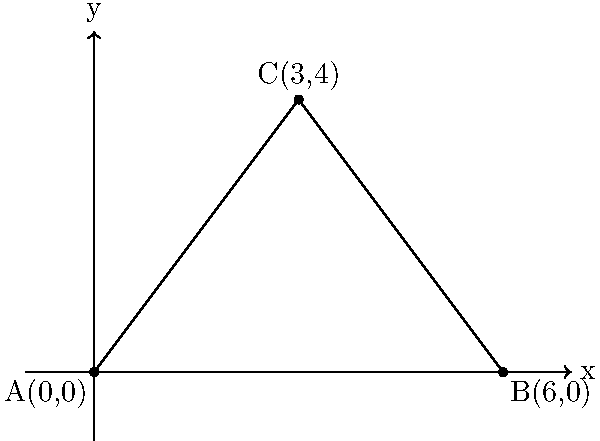As a supportive parent, you're helping your child understand geometry before their tattoo removal appointment. Given two points A(0,0) and B(6,0), find the coordinates of point C that forms an isosceles triangle ABC where AC = BC. The height of the triangle is 4 units. Let's approach this step-by-step:

1) Since A(0,0) and B(6,0) are on the x-axis, the base of the triangle is 6 units long.

2) The height of the triangle is given as 4 units, so C will be 4 units above the x-axis.

3) For an isosceles triangle with AC = BC, point C must be equidistant from A and B. This means C will be directly above the midpoint of AB.

4) The midpoint of AB is at $(\frac{0+6}{2}, 0) = (3,0)$.

5) Therefore, the coordinates of C will be (3,4).

To verify:
- AC = $\sqrt{3^2 + 4^2} = 5$
- BC = $\sqrt{3^2 + 4^2} = 5$

Thus, AC = BC, confirming that ABC is indeed an isosceles triangle.
Answer: C(3,4) 